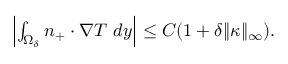<formula> <loc_0><loc_0><loc_500><loc_500>\begin{array} { r } { \left | \int _ { \Omega _ { \delta } } n _ { + } \cdot \nabla T \ d y \right | \leq C ( 1 + \delta \| \kappa \| _ { \infty } ) . } \end{array}</formula> 